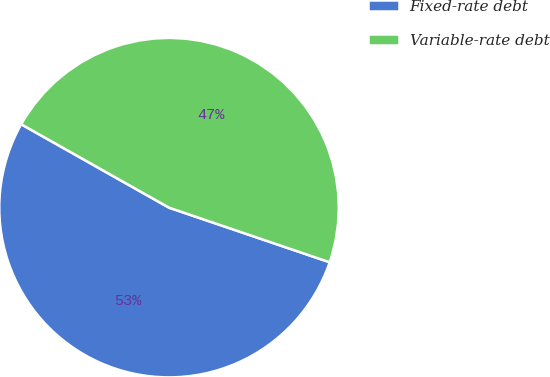Convert chart. <chart><loc_0><loc_0><loc_500><loc_500><pie_chart><fcel>Fixed-rate debt<fcel>Variable-rate debt<nl><fcel>52.96%<fcel>47.04%<nl></chart> 